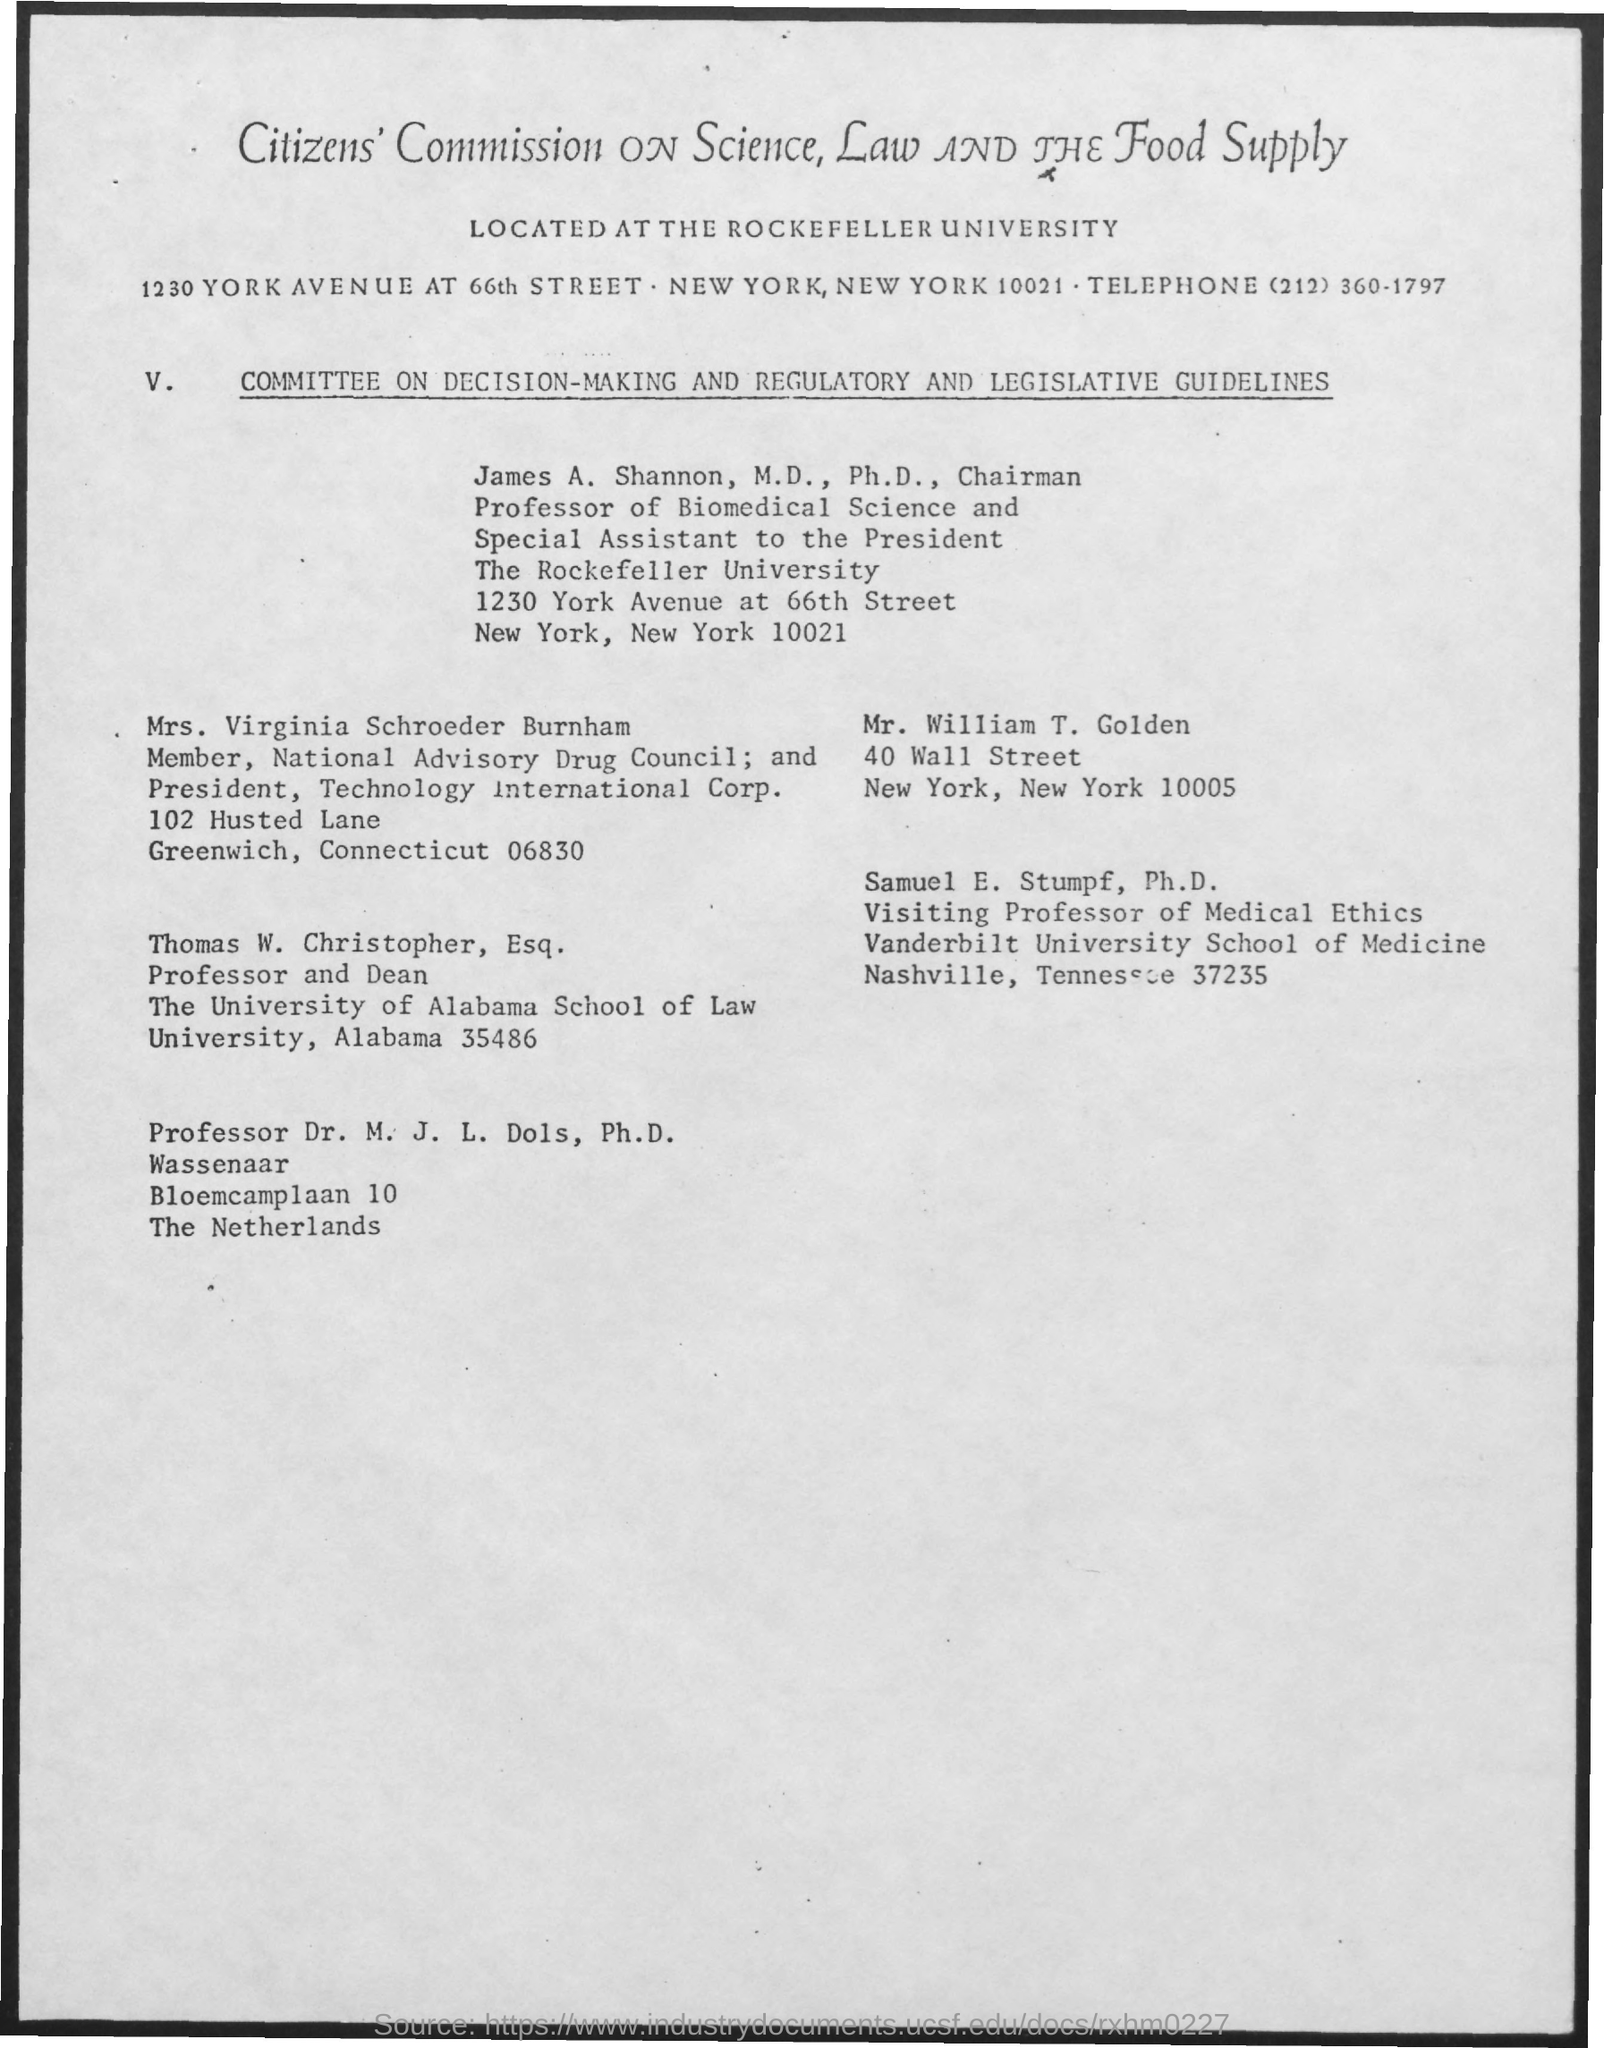Citizens' Commission on science,law and the food supply is located at which university?
Make the answer very short. Rockefeller university. What is the telephone number mentioned in the document?
Offer a very short reply. (212) 360-1797. 